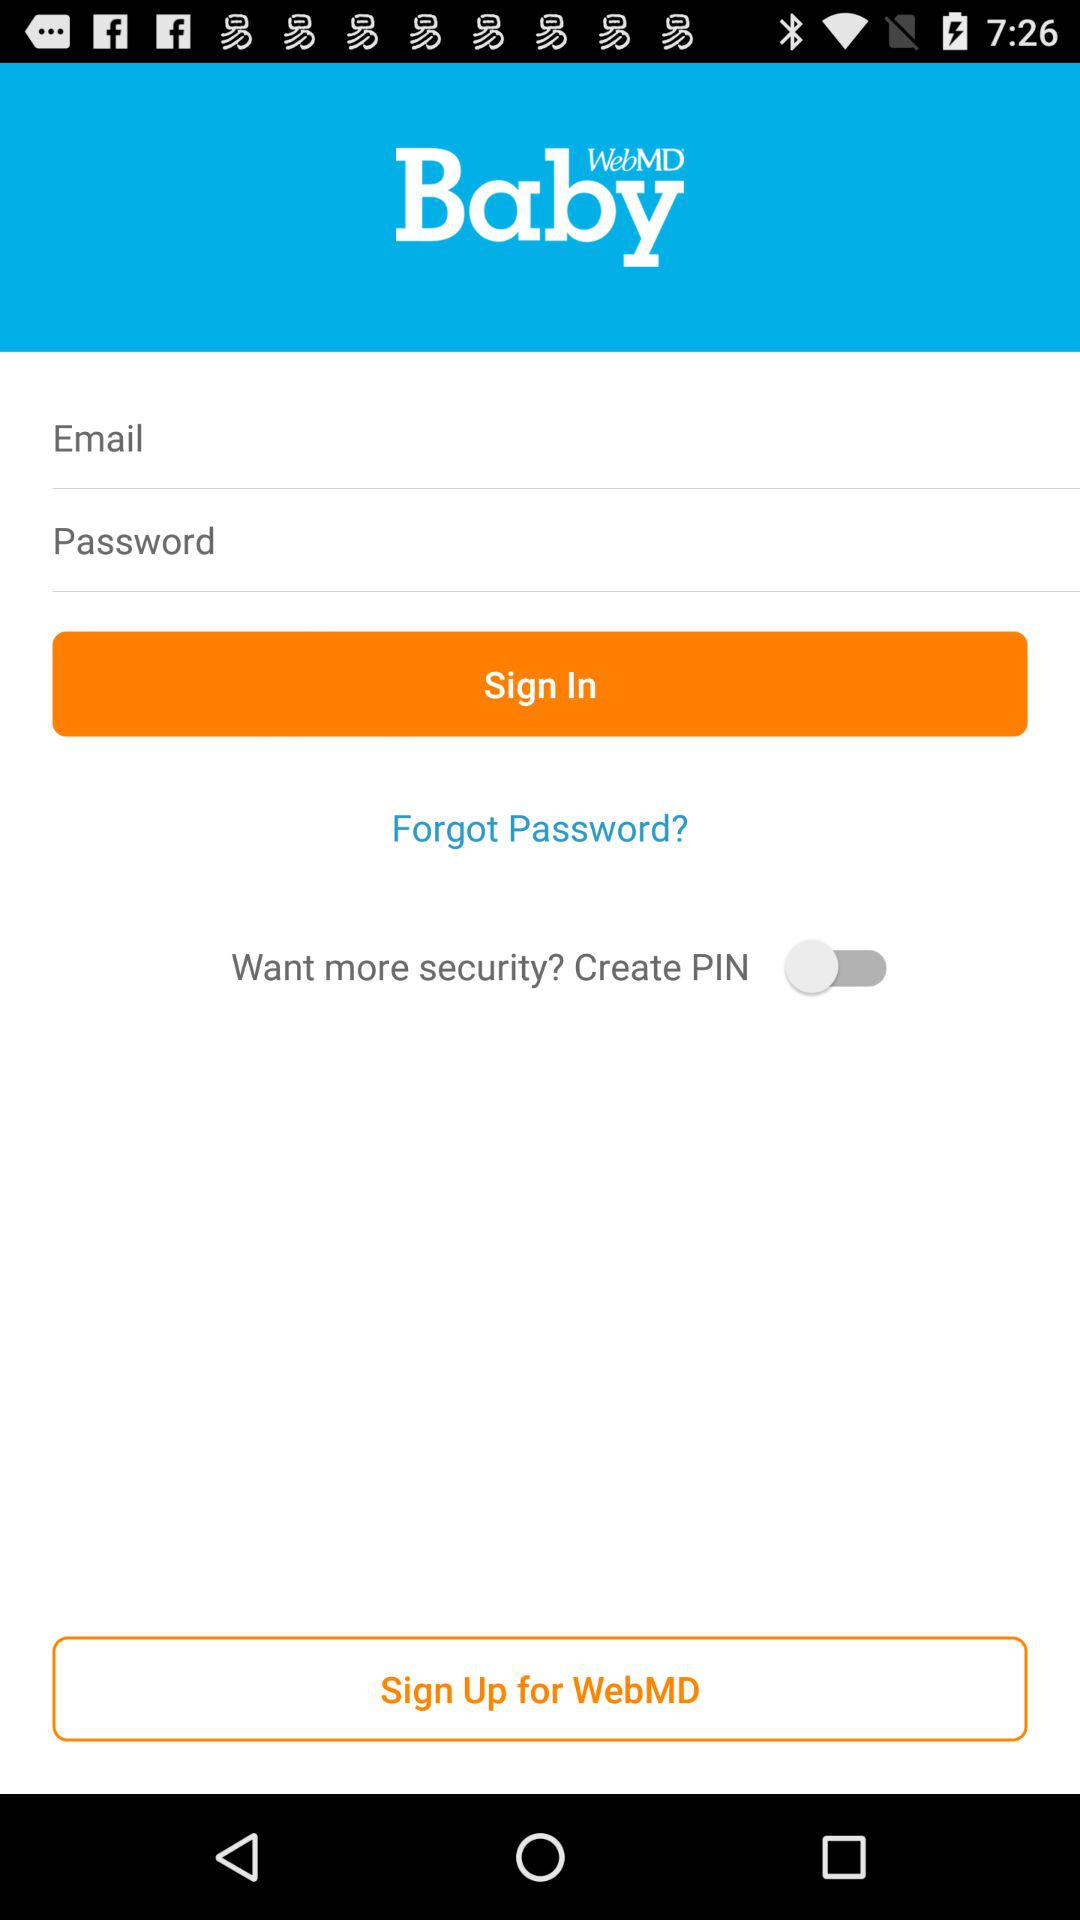What is the status of "Want more security"? The status is "off". 